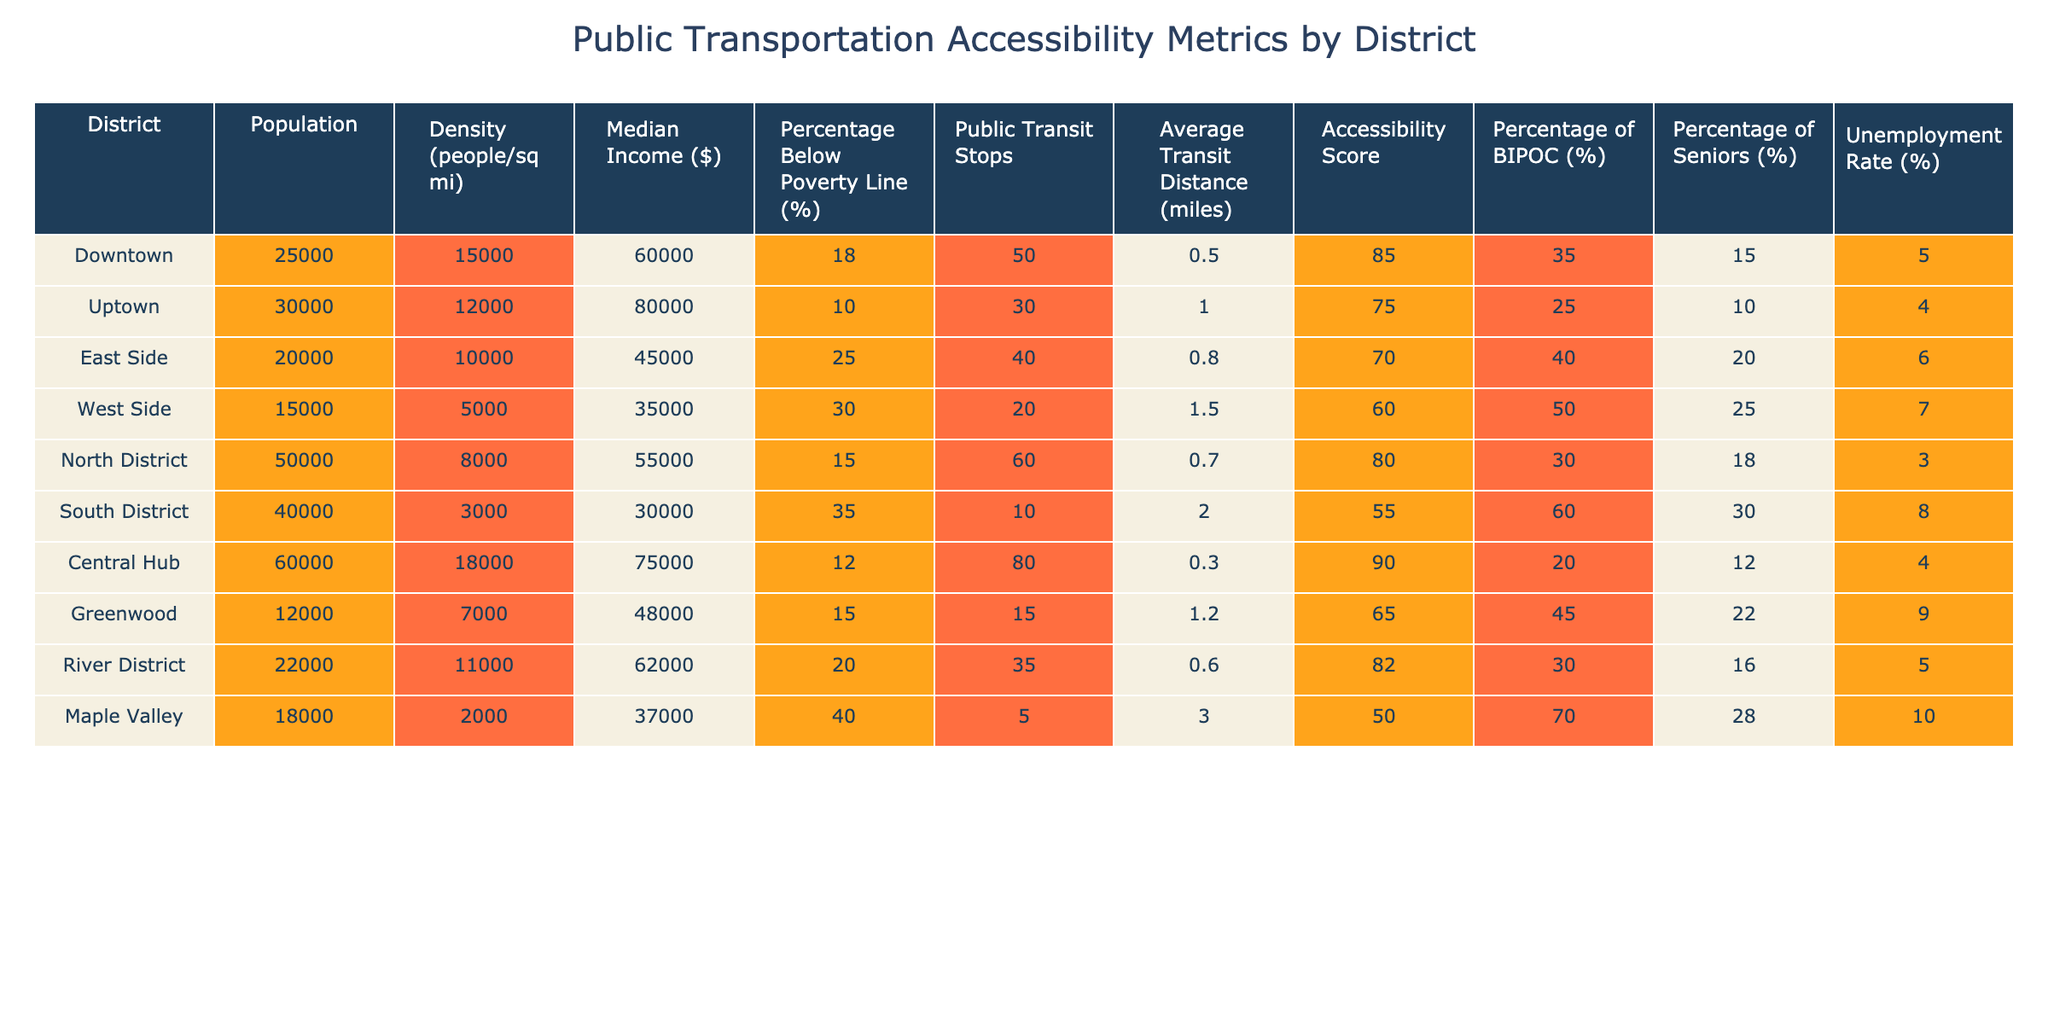What is the median income in the South District? The table shows that the median income for the South District is $30,000 as listed under the "Median Income ($)" column.
Answer: $30,000 Which district has the highest population? By comparing the values in the "Population" column, the Central Hub has the highest population at 60,000.
Answer: Central Hub What is the average accessibility score for districts with a population over 25,000? The districts with populations over 25,000 are Downtown, Uptown, Central Hub, and South District. Their accessibility scores are 85, 75, 90, and 55, respectively. The sum is 85 + 75 + 90 + 55 = 305. Dividing by 4 gives an average of 305 / 4 = 76.25.
Answer: 76.25 Is the percentage of BIPOC in the East Side greater than that in the Uptown? According to the table, the East Side has 40% BIPOC while Uptown has 25%. Since 40% is greater than 25%, the statement is true.
Answer: Yes What is the total number of public transit stops across all districts? The total number of public transit stops can be calculated by summing the values in the "Public Transit Stops" column: 50 + 30 + 40 + 20 + 60 + 10 + 80 + 15 + 35 + 5 = 345.
Answer: 345 Which district has the lowest average transit distance, and what is that distance? By examining the values in the "Average Transit Distance (miles)" column, we see that the Central Hub has the lowest distance at 0.3 miles.
Answer: Central Hub, 0.3 miles What is the unemployment rate difference between Maple Valley and East Side? The unemployment rate for Maple Valley is 10%, and for East Side, it is 6%. The difference is 10% - 6% = 4%.
Answer: 4% Does the North District have a higher percentage of seniors compared to the Central Hub? The North District has 18% seniors and the Central Hub has 12%. Since 18% is greater than 12%, the North District indeed has a higher percentage.
Answer: Yes What percentage of the population in the West Side is below the poverty line? The "Percentage Below Poverty Line (%)" for the West Side is listed as 30% in the table.
Answer: 30% If we combined the populations of the Downtown and East Side districts, how many people would that be? The populations are 25,000 for Downtown and 20,000 for East Side. Adding them together gives 25,000 + 20,000 = 45,000.
Answer: 45,000 